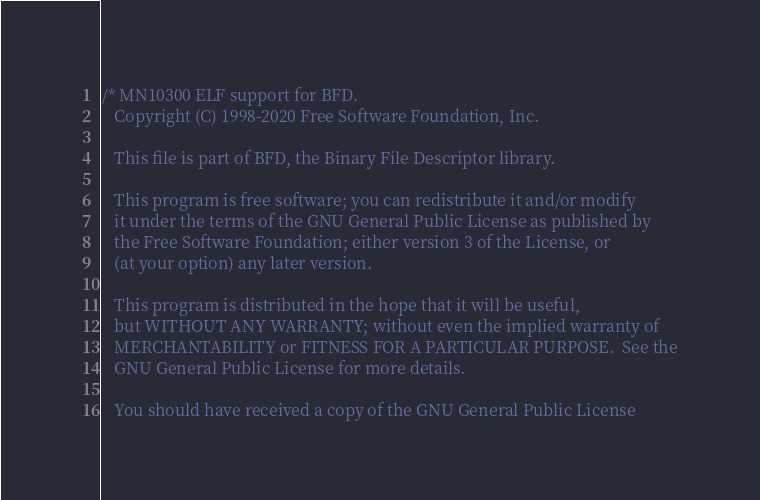Convert code to text. <code><loc_0><loc_0><loc_500><loc_500><_C_>/* MN10300 ELF support for BFD.
   Copyright (C) 1998-2020 Free Software Foundation, Inc.

   This file is part of BFD, the Binary File Descriptor library.

   This program is free software; you can redistribute it and/or modify
   it under the terms of the GNU General Public License as published by
   the Free Software Foundation; either version 3 of the License, or
   (at your option) any later version.

   This program is distributed in the hope that it will be useful,
   but WITHOUT ANY WARRANTY; without even the implied warranty of
   MERCHANTABILITY or FITNESS FOR A PARTICULAR PURPOSE.  See the
   GNU General Public License for more details.

   You should have received a copy of the GNU General Public License</code> 